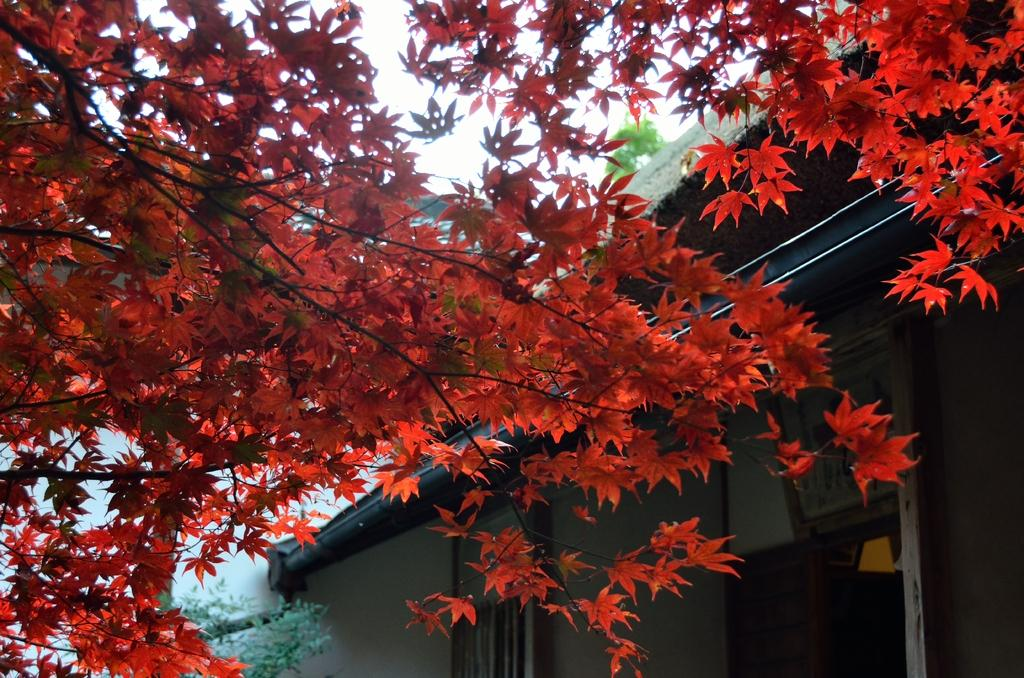What is the main object in the picture? There is a tree in the picture. What is unique about the tree's appearance? The tree has light red color leaves. Is there any other structure near the tree? Yes, there is a house beside the tree. What type of attention is the tree giving to the list in the image? There is no list present in the image, and the tree is not capable of giving attention. 